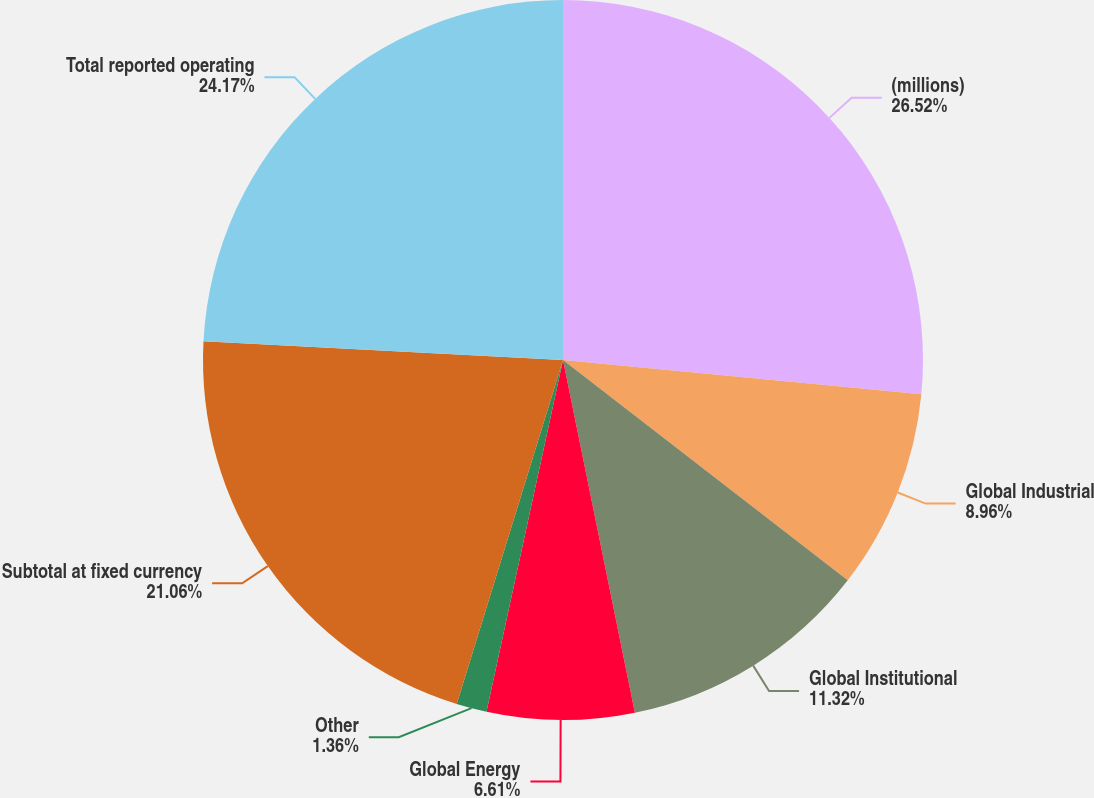Convert chart to OTSL. <chart><loc_0><loc_0><loc_500><loc_500><pie_chart><fcel>(millions)<fcel>Global Industrial<fcel>Global Institutional<fcel>Global Energy<fcel>Other<fcel>Subtotal at fixed currency<fcel>Total reported operating<nl><fcel>26.52%<fcel>8.96%<fcel>11.32%<fcel>6.61%<fcel>1.36%<fcel>21.06%<fcel>24.17%<nl></chart> 